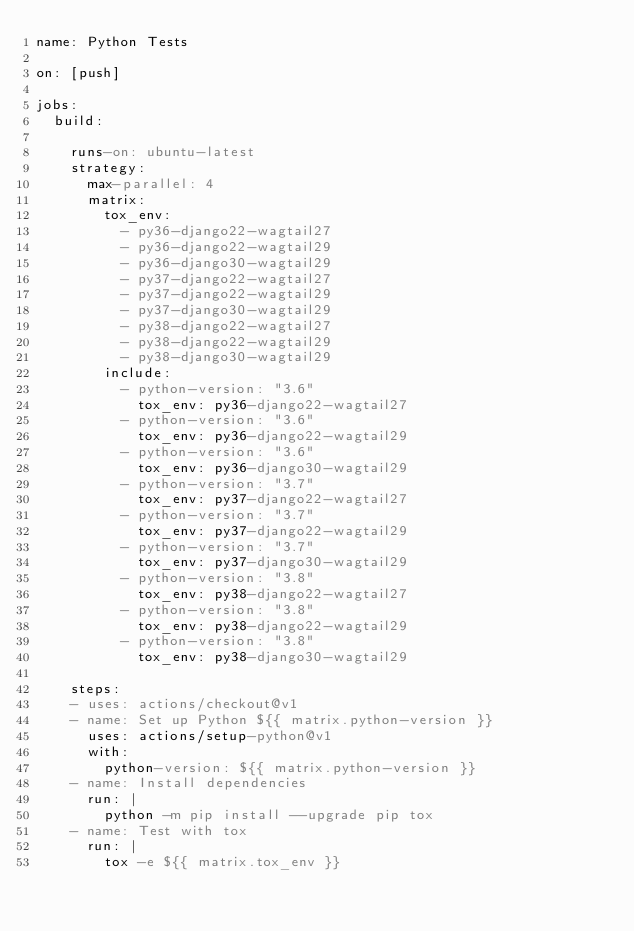<code> <loc_0><loc_0><loc_500><loc_500><_YAML_>name: Python Tests

on: [push]

jobs:
  build:

    runs-on: ubuntu-latest
    strategy:
      max-parallel: 4
      matrix:
        tox_env:
          - py36-django22-wagtail27
          - py36-django22-wagtail29
          - py36-django30-wagtail29
          - py37-django22-wagtail27
          - py37-django22-wagtail29
          - py37-django30-wagtail29
          - py38-django22-wagtail27
          - py38-django22-wagtail29
          - py38-django30-wagtail29
        include:
          - python-version: "3.6"
            tox_env: py36-django22-wagtail27
          - python-version: "3.6"
            tox_env: py36-django22-wagtail29
          - python-version: "3.6"
            tox_env: py36-django30-wagtail29
          - python-version: "3.7"
            tox_env: py37-django22-wagtail27
          - python-version: "3.7"
            tox_env: py37-django22-wagtail29
          - python-version: "3.7"
            tox_env: py37-django30-wagtail29
          - python-version: "3.8"
            tox_env: py38-django22-wagtail27
          - python-version: "3.8"
            tox_env: py38-django22-wagtail29
          - python-version: "3.8"
            tox_env: py38-django30-wagtail29

    steps:
    - uses: actions/checkout@v1
    - name: Set up Python ${{ matrix.python-version }}
      uses: actions/setup-python@v1
      with:
        python-version: ${{ matrix.python-version }}
    - name: Install dependencies
      run: |
        python -m pip install --upgrade pip tox
    - name: Test with tox
      run: |
        tox -e ${{ matrix.tox_env }}
</code> 